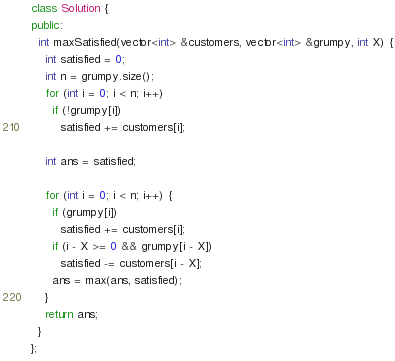<code> <loc_0><loc_0><loc_500><loc_500><_C++_>class Solution {
public:
  int maxSatisfied(vector<int> &customers, vector<int> &grumpy, int X) {
    int satisfied = 0;
    int n = grumpy.size();
    for (int i = 0; i < n; i++)
      if (!grumpy[i])
        satisfied += customers[i];

    int ans = satisfied;

    for (int i = 0; i < n; i++) {
      if (grumpy[i])
        satisfied += customers[i];
      if (i - X >= 0 && grumpy[i - X])
        satisfied -= customers[i - X];
      ans = max(ans, satisfied);
    }
    return ans;
  }
};
</code> 